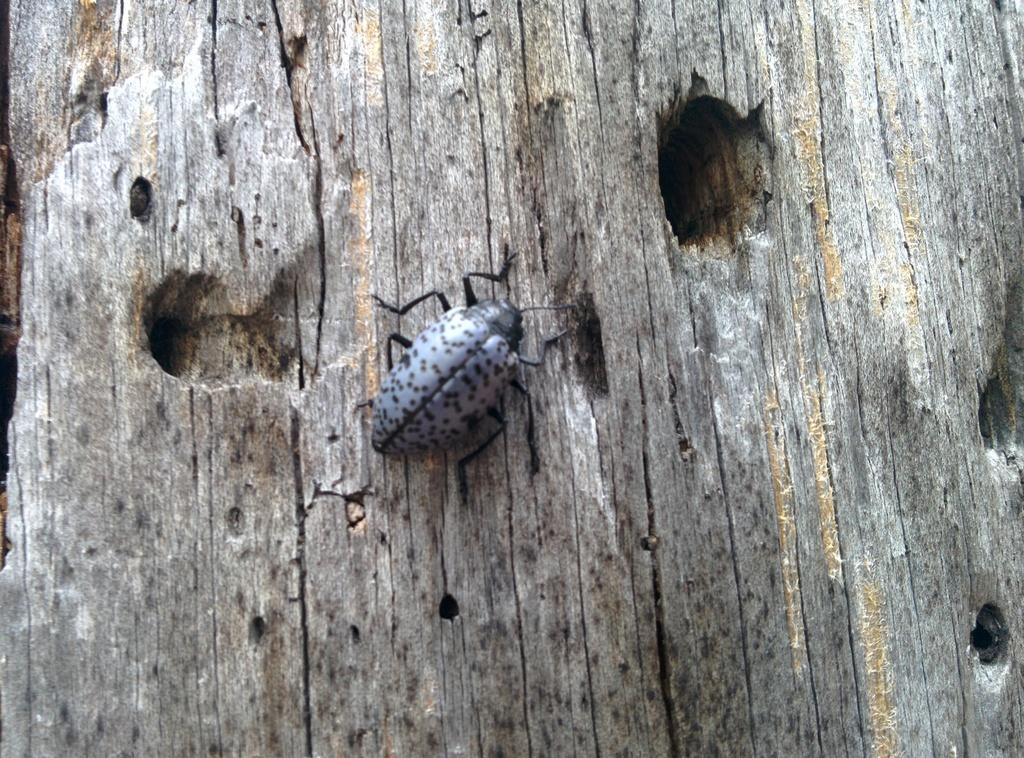In one or two sentences, can you explain what this image depicts? This image consists of an insect on the tree. In the background, there is a tree. 